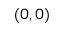<formula> <loc_0><loc_0><loc_500><loc_500>( 0 , 0 )</formula> 